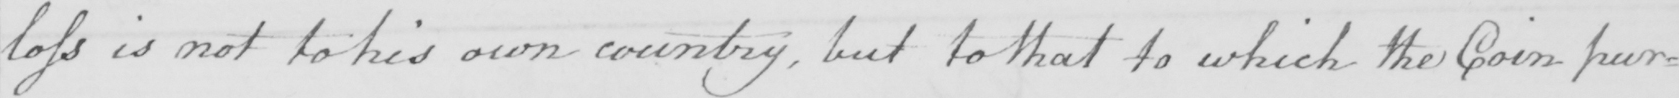Please transcribe the handwritten text in this image. loss is not to his own country , but to that to which the Coin pur= 